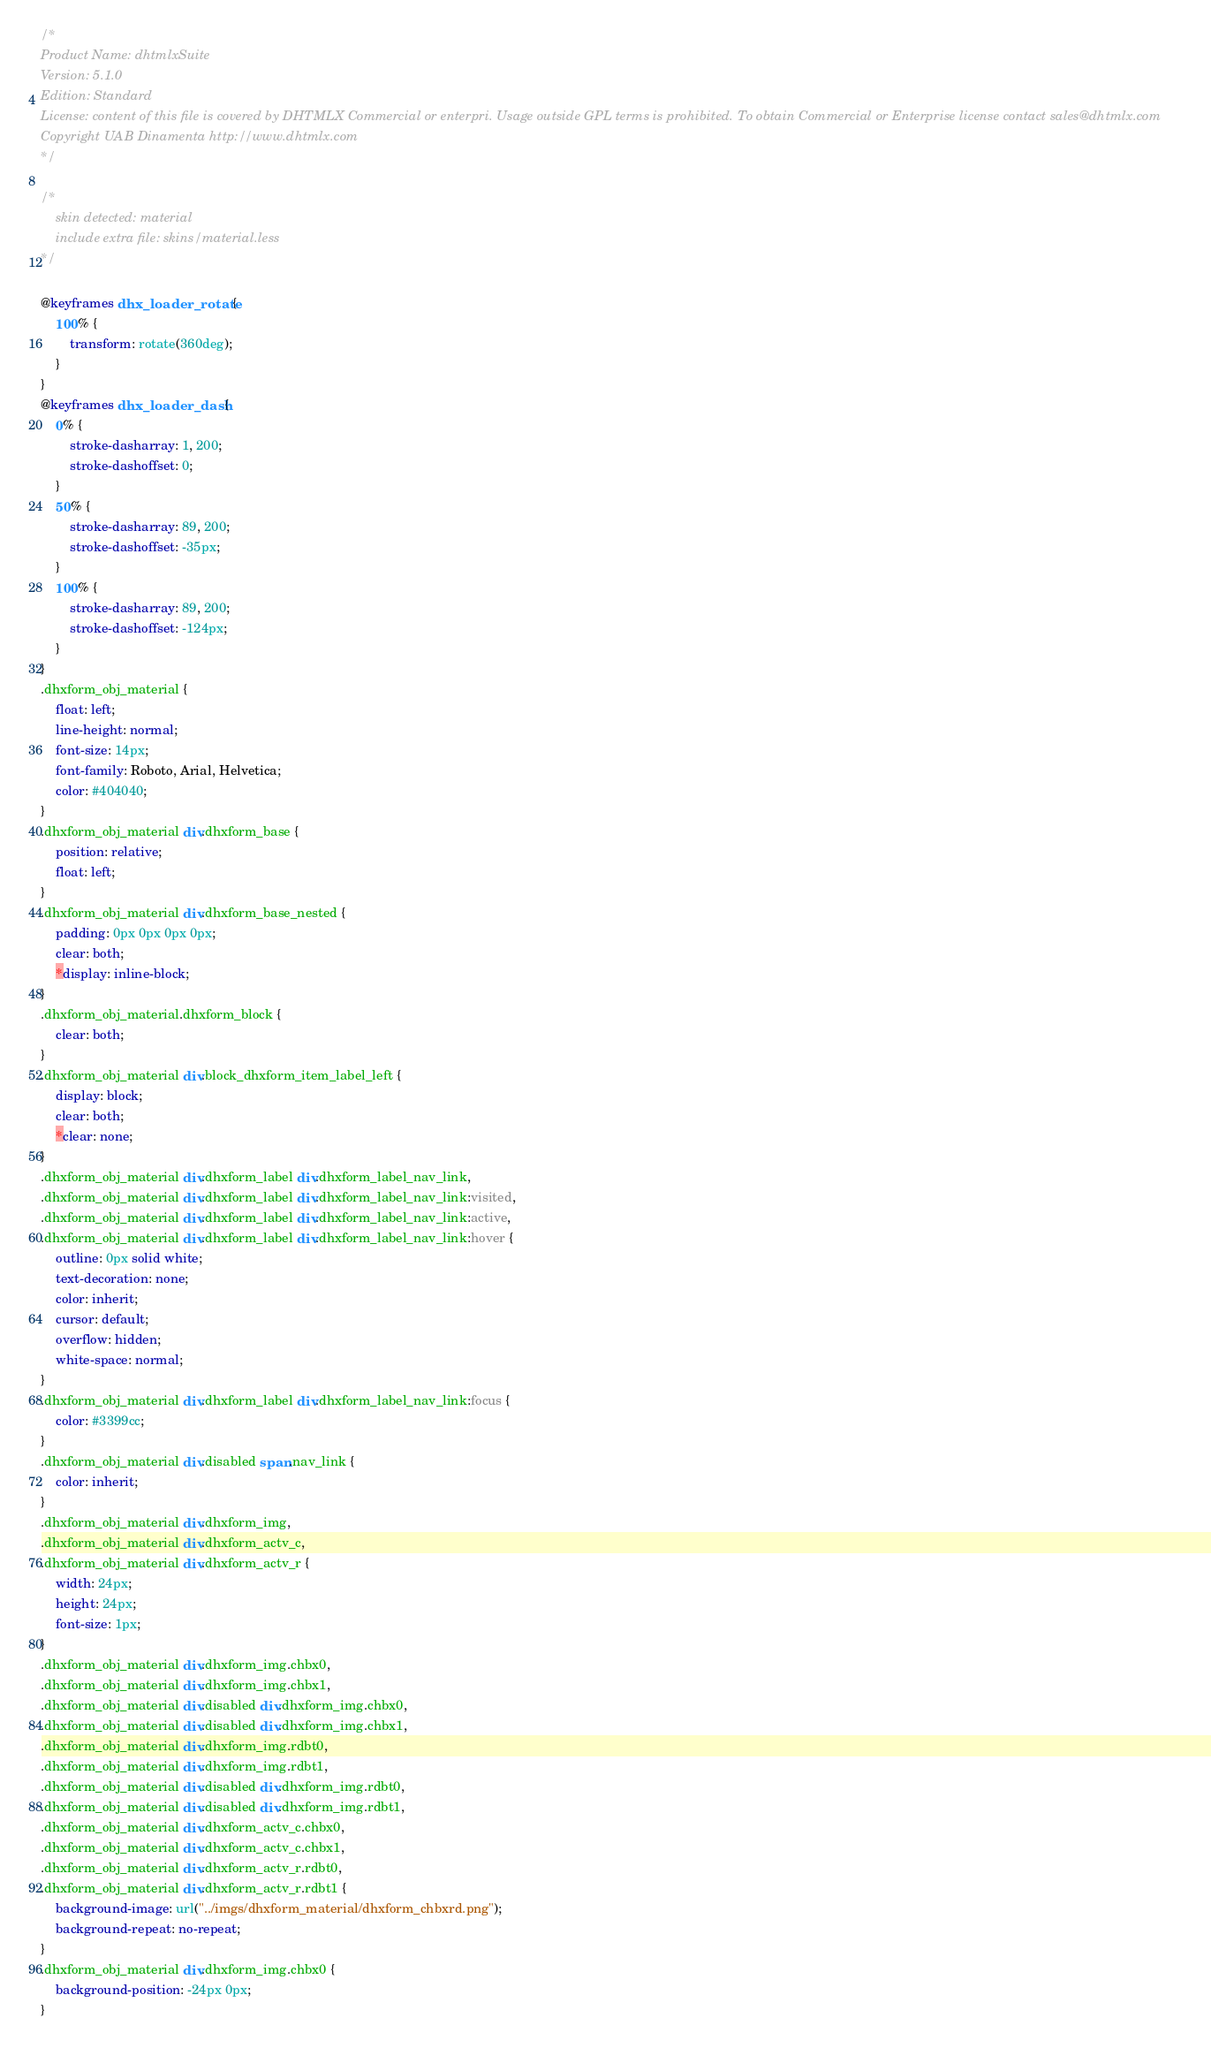Convert code to text. <code><loc_0><loc_0><loc_500><loc_500><_CSS_>/*
Product Name: dhtmlxSuite 
Version: 5.1.0 
Edition: Standard 
License: content of this file is covered by DHTMLX Commercial or enterpri. Usage outside GPL terms is prohibited. To obtain Commercial or Enterprise license contact sales@dhtmlx.com
Copyright UAB Dinamenta http://www.dhtmlx.com
*/

/*
	skin detected: material
	include extra file: skins/material.less
*/

@keyframes dhx_loader_rotate {
	100% {
		transform: rotate(360deg);
	}
}
@keyframes dhx_loader_dash {
	0% {
		stroke-dasharray: 1, 200;
		stroke-dashoffset: 0;
	}
	50% {
		stroke-dasharray: 89, 200;
		stroke-dashoffset: -35px;
	}
	100% {
		stroke-dasharray: 89, 200;
		stroke-dashoffset: -124px;
	}
}
.dhxform_obj_material {
	float: left;
	line-height: normal;
	font-size: 14px;
	font-family: Roboto, Arial, Helvetica;
	color: #404040;
}
.dhxform_obj_material div.dhxform_base {
	position: relative;
	float: left;
}
.dhxform_obj_material div.dhxform_base_nested {
	padding: 0px 0px 0px 0px;
	clear: both;
	*display: inline-block;
}
.dhxform_obj_material.dhxform_block {
	clear: both;
}
.dhxform_obj_material div.block_dhxform_item_label_left {
	display: block;
	clear: both;
	*clear: none;
}
.dhxform_obj_material div.dhxform_label div.dhxform_label_nav_link,
.dhxform_obj_material div.dhxform_label div.dhxform_label_nav_link:visited,
.dhxform_obj_material div.dhxform_label div.dhxform_label_nav_link:active,
.dhxform_obj_material div.dhxform_label div.dhxform_label_nav_link:hover {
	outline: 0px solid white;
	text-decoration: none;
	color: inherit;
	cursor: default;
	overflow: hidden;
	white-space: normal;
}
.dhxform_obj_material div.dhxform_label div.dhxform_label_nav_link:focus {
	color: #3399cc;
}
.dhxform_obj_material div.disabled span.nav_link {
	color: inherit;
}
.dhxform_obj_material div.dhxform_img,
.dhxform_obj_material div.dhxform_actv_c,
.dhxform_obj_material div.dhxform_actv_r {
	width: 24px;
	height: 24px;
	font-size: 1px;
}
.dhxform_obj_material div.dhxform_img.chbx0,
.dhxform_obj_material div.dhxform_img.chbx1,
.dhxform_obj_material div.disabled div.dhxform_img.chbx0,
.dhxform_obj_material div.disabled div.dhxform_img.chbx1,
.dhxform_obj_material div.dhxform_img.rdbt0,
.dhxform_obj_material div.dhxform_img.rdbt1,
.dhxform_obj_material div.disabled div.dhxform_img.rdbt0,
.dhxform_obj_material div.disabled div.dhxform_img.rdbt1,
.dhxform_obj_material div.dhxform_actv_c.chbx0,
.dhxform_obj_material div.dhxform_actv_c.chbx1,
.dhxform_obj_material div.dhxform_actv_r.rdbt0,
.dhxform_obj_material div.dhxform_actv_r.rdbt1 {
	background-image: url("../imgs/dhxform_material/dhxform_chbxrd.png");
	background-repeat: no-repeat;
}
.dhxform_obj_material div.dhxform_img.chbx0 {
	background-position: -24px 0px;
}</code> 